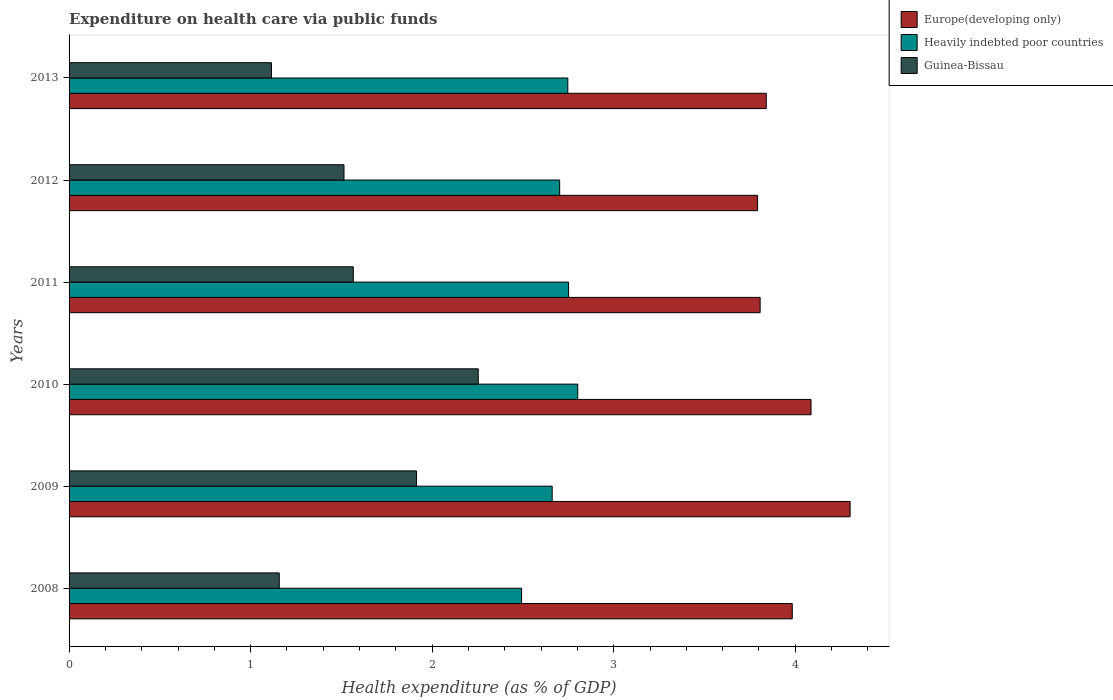How many different coloured bars are there?
Your answer should be compact. 3. How many groups of bars are there?
Make the answer very short. 6. Are the number of bars on each tick of the Y-axis equal?
Provide a short and direct response. Yes. How many bars are there on the 5th tick from the bottom?
Keep it short and to the point. 3. What is the label of the 4th group of bars from the top?
Provide a succinct answer. 2010. In how many cases, is the number of bars for a given year not equal to the number of legend labels?
Your response must be concise. 0. What is the expenditure made on health care in Guinea-Bissau in 2008?
Your answer should be compact. 1.16. Across all years, what is the maximum expenditure made on health care in Heavily indebted poor countries?
Provide a succinct answer. 2.8. Across all years, what is the minimum expenditure made on health care in Europe(developing only)?
Ensure brevity in your answer.  3.79. In which year was the expenditure made on health care in Europe(developing only) maximum?
Keep it short and to the point. 2009. In which year was the expenditure made on health care in Europe(developing only) minimum?
Your answer should be very brief. 2012. What is the total expenditure made on health care in Guinea-Bissau in the graph?
Give a very brief answer. 9.52. What is the difference between the expenditure made on health care in Guinea-Bissau in 2010 and that in 2011?
Offer a terse response. 0.69. What is the difference between the expenditure made on health care in Guinea-Bissau in 2010 and the expenditure made on health care in Europe(developing only) in 2008?
Give a very brief answer. -1.73. What is the average expenditure made on health care in Europe(developing only) per year?
Offer a very short reply. 3.97. In the year 2011, what is the difference between the expenditure made on health care in Europe(developing only) and expenditure made on health care in Guinea-Bissau?
Your response must be concise. 2.24. In how many years, is the expenditure made on health care in Europe(developing only) greater than 2.8 %?
Offer a terse response. 6. What is the ratio of the expenditure made on health care in Guinea-Bissau in 2010 to that in 2011?
Your answer should be very brief. 1.44. Is the difference between the expenditure made on health care in Europe(developing only) in 2010 and 2012 greater than the difference between the expenditure made on health care in Guinea-Bissau in 2010 and 2012?
Your response must be concise. No. What is the difference between the highest and the second highest expenditure made on health care in Guinea-Bissau?
Your response must be concise. 0.34. What is the difference between the highest and the lowest expenditure made on health care in Europe(developing only)?
Provide a succinct answer. 0.51. In how many years, is the expenditure made on health care in Heavily indebted poor countries greater than the average expenditure made on health care in Heavily indebted poor countries taken over all years?
Your answer should be compact. 4. What does the 1st bar from the top in 2010 represents?
Your response must be concise. Guinea-Bissau. What does the 2nd bar from the bottom in 2013 represents?
Offer a very short reply. Heavily indebted poor countries. Is it the case that in every year, the sum of the expenditure made on health care in Guinea-Bissau and expenditure made on health care in Heavily indebted poor countries is greater than the expenditure made on health care in Europe(developing only)?
Ensure brevity in your answer.  No. How many bars are there?
Provide a short and direct response. 18. What is the difference between two consecutive major ticks on the X-axis?
Offer a very short reply. 1. Are the values on the major ticks of X-axis written in scientific E-notation?
Keep it short and to the point. No. Where does the legend appear in the graph?
Keep it short and to the point. Top right. How many legend labels are there?
Provide a short and direct response. 3. How are the legend labels stacked?
Provide a succinct answer. Vertical. What is the title of the graph?
Keep it short and to the point. Expenditure on health care via public funds. Does "Sint Maarten (Dutch part)" appear as one of the legend labels in the graph?
Give a very brief answer. No. What is the label or title of the X-axis?
Offer a very short reply. Health expenditure (as % of GDP). What is the Health expenditure (as % of GDP) of Europe(developing only) in 2008?
Provide a succinct answer. 3.98. What is the Health expenditure (as % of GDP) in Heavily indebted poor countries in 2008?
Provide a succinct answer. 2.49. What is the Health expenditure (as % of GDP) in Guinea-Bissau in 2008?
Your response must be concise. 1.16. What is the Health expenditure (as % of GDP) of Europe(developing only) in 2009?
Provide a short and direct response. 4.3. What is the Health expenditure (as % of GDP) in Heavily indebted poor countries in 2009?
Offer a very short reply. 2.66. What is the Health expenditure (as % of GDP) of Guinea-Bissau in 2009?
Your answer should be compact. 1.91. What is the Health expenditure (as % of GDP) of Europe(developing only) in 2010?
Make the answer very short. 4.09. What is the Health expenditure (as % of GDP) in Heavily indebted poor countries in 2010?
Your answer should be compact. 2.8. What is the Health expenditure (as % of GDP) in Guinea-Bissau in 2010?
Give a very brief answer. 2.25. What is the Health expenditure (as % of GDP) of Europe(developing only) in 2011?
Provide a succinct answer. 3.81. What is the Health expenditure (as % of GDP) in Heavily indebted poor countries in 2011?
Make the answer very short. 2.75. What is the Health expenditure (as % of GDP) of Guinea-Bissau in 2011?
Provide a short and direct response. 1.57. What is the Health expenditure (as % of GDP) of Europe(developing only) in 2012?
Provide a short and direct response. 3.79. What is the Health expenditure (as % of GDP) in Heavily indebted poor countries in 2012?
Offer a very short reply. 2.7. What is the Health expenditure (as % of GDP) in Guinea-Bissau in 2012?
Offer a terse response. 1.51. What is the Health expenditure (as % of GDP) in Europe(developing only) in 2013?
Offer a terse response. 3.84. What is the Health expenditure (as % of GDP) of Heavily indebted poor countries in 2013?
Your answer should be very brief. 2.75. What is the Health expenditure (as % of GDP) in Guinea-Bissau in 2013?
Keep it short and to the point. 1.11. Across all years, what is the maximum Health expenditure (as % of GDP) in Europe(developing only)?
Your answer should be very brief. 4.3. Across all years, what is the maximum Health expenditure (as % of GDP) in Heavily indebted poor countries?
Your answer should be compact. 2.8. Across all years, what is the maximum Health expenditure (as % of GDP) of Guinea-Bissau?
Offer a very short reply. 2.25. Across all years, what is the minimum Health expenditure (as % of GDP) in Europe(developing only)?
Your response must be concise. 3.79. Across all years, what is the minimum Health expenditure (as % of GDP) in Heavily indebted poor countries?
Give a very brief answer. 2.49. Across all years, what is the minimum Health expenditure (as % of GDP) of Guinea-Bissau?
Your answer should be compact. 1.11. What is the total Health expenditure (as % of GDP) in Europe(developing only) in the graph?
Offer a terse response. 23.81. What is the total Health expenditure (as % of GDP) in Heavily indebted poor countries in the graph?
Your response must be concise. 16.16. What is the total Health expenditure (as % of GDP) in Guinea-Bissau in the graph?
Provide a succinct answer. 9.52. What is the difference between the Health expenditure (as % of GDP) of Europe(developing only) in 2008 and that in 2009?
Offer a terse response. -0.32. What is the difference between the Health expenditure (as % of GDP) in Heavily indebted poor countries in 2008 and that in 2009?
Your answer should be compact. -0.17. What is the difference between the Health expenditure (as % of GDP) in Guinea-Bissau in 2008 and that in 2009?
Ensure brevity in your answer.  -0.76. What is the difference between the Health expenditure (as % of GDP) of Europe(developing only) in 2008 and that in 2010?
Your answer should be very brief. -0.1. What is the difference between the Health expenditure (as % of GDP) of Heavily indebted poor countries in 2008 and that in 2010?
Provide a succinct answer. -0.31. What is the difference between the Health expenditure (as % of GDP) of Guinea-Bissau in 2008 and that in 2010?
Make the answer very short. -1.1. What is the difference between the Health expenditure (as % of GDP) in Europe(developing only) in 2008 and that in 2011?
Make the answer very short. 0.18. What is the difference between the Health expenditure (as % of GDP) in Heavily indebted poor countries in 2008 and that in 2011?
Your answer should be compact. -0.26. What is the difference between the Health expenditure (as % of GDP) of Guinea-Bissau in 2008 and that in 2011?
Provide a short and direct response. -0.41. What is the difference between the Health expenditure (as % of GDP) of Europe(developing only) in 2008 and that in 2012?
Your answer should be compact. 0.19. What is the difference between the Health expenditure (as % of GDP) of Heavily indebted poor countries in 2008 and that in 2012?
Ensure brevity in your answer.  -0.21. What is the difference between the Health expenditure (as % of GDP) in Guinea-Bissau in 2008 and that in 2012?
Your answer should be compact. -0.36. What is the difference between the Health expenditure (as % of GDP) in Europe(developing only) in 2008 and that in 2013?
Provide a short and direct response. 0.14. What is the difference between the Health expenditure (as % of GDP) of Heavily indebted poor countries in 2008 and that in 2013?
Offer a very short reply. -0.25. What is the difference between the Health expenditure (as % of GDP) in Guinea-Bissau in 2008 and that in 2013?
Offer a terse response. 0.04. What is the difference between the Health expenditure (as % of GDP) in Europe(developing only) in 2009 and that in 2010?
Your answer should be compact. 0.22. What is the difference between the Health expenditure (as % of GDP) in Heavily indebted poor countries in 2009 and that in 2010?
Offer a very short reply. -0.14. What is the difference between the Health expenditure (as % of GDP) in Guinea-Bissau in 2009 and that in 2010?
Provide a short and direct response. -0.34. What is the difference between the Health expenditure (as % of GDP) of Europe(developing only) in 2009 and that in 2011?
Your answer should be very brief. 0.5. What is the difference between the Health expenditure (as % of GDP) in Heavily indebted poor countries in 2009 and that in 2011?
Ensure brevity in your answer.  -0.09. What is the difference between the Health expenditure (as % of GDP) in Guinea-Bissau in 2009 and that in 2011?
Offer a terse response. 0.35. What is the difference between the Health expenditure (as % of GDP) of Europe(developing only) in 2009 and that in 2012?
Give a very brief answer. 0.51. What is the difference between the Health expenditure (as % of GDP) of Heavily indebted poor countries in 2009 and that in 2012?
Your answer should be very brief. -0.04. What is the difference between the Health expenditure (as % of GDP) of Guinea-Bissau in 2009 and that in 2012?
Keep it short and to the point. 0.4. What is the difference between the Health expenditure (as % of GDP) in Europe(developing only) in 2009 and that in 2013?
Provide a succinct answer. 0.46. What is the difference between the Health expenditure (as % of GDP) of Heavily indebted poor countries in 2009 and that in 2013?
Your answer should be compact. -0.09. What is the difference between the Health expenditure (as % of GDP) of Guinea-Bissau in 2009 and that in 2013?
Your answer should be very brief. 0.8. What is the difference between the Health expenditure (as % of GDP) in Europe(developing only) in 2010 and that in 2011?
Your answer should be very brief. 0.28. What is the difference between the Health expenditure (as % of GDP) in Heavily indebted poor countries in 2010 and that in 2011?
Offer a terse response. 0.05. What is the difference between the Health expenditure (as % of GDP) in Guinea-Bissau in 2010 and that in 2011?
Your answer should be compact. 0.69. What is the difference between the Health expenditure (as % of GDP) of Europe(developing only) in 2010 and that in 2012?
Ensure brevity in your answer.  0.29. What is the difference between the Health expenditure (as % of GDP) of Heavily indebted poor countries in 2010 and that in 2012?
Provide a succinct answer. 0.1. What is the difference between the Health expenditure (as % of GDP) of Guinea-Bissau in 2010 and that in 2012?
Your answer should be very brief. 0.74. What is the difference between the Health expenditure (as % of GDP) of Europe(developing only) in 2010 and that in 2013?
Offer a very short reply. 0.25. What is the difference between the Health expenditure (as % of GDP) in Heavily indebted poor countries in 2010 and that in 2013?
Make the answer very short. 0.05. What is the difference between the Health expenditure (as % of GDP) in Guinea-Bissau in 2010 and that in 2013?
Provide a succinct answer. 1.14. What is the difference between the Health expenditure (as % of GDP) of Europe(developing only) in 2011 and that in 2012?
Offer a very short reply. 0.01. What is the difference between the Health expenditure (as % of GDP) in Heavily indebted poor countries in 2011 and that in 2012?
Your answer should be very brief. 0.05. What is the difference between the Health expenditure (as % of GDP) in Guinea-Bissau in 2011 and that in 2012?
Offer a terse response. 0.05. What is the difference between the Health expenditure (as % of GDP) of Europe(developing only) in 2011 and that in 2013?
Ensure brevity in your answer.  -0.03. What is the difference between the Health expenditure (as % of GDP) of Heavily indebted poor countries in 2011 and that in 2013?
Your answer should be compact. 0. What is the difference between the Health expenditure (as % of GDP) of Guinea-Bissau in 2011 and that in 2013?
Make the answer very short. 0.45. What is the difference between the Health expenditure (as % of GDP) in Europe(developing only) in 2012 and that in 2013?
Offer a terse response. -0.05. What is the difference between the Health expenditure (as % of GDP) in Heavily indebted poor countries in 2012 and that in 2013?
Ensure brevity in your answer.  -0.04. What is the difference between the Health expenditure (as % of GDP) of Guinea-Bissau in 2012 and that in 2013?
Offer a terse response. 0.4. What is the difference between the Health expenditure (as % of GDP) in Europe(developing only) in 2008 and the Health expenditure (as % of GDP) in Heavily indebted poor countries in 2009?
Your answer should be compact. 1.32. What is the difference between the Health expenditure (as % of GDP) of Europe(developing only) in 2008 and the Health expenditure (as % of GDP) of Guinea-Bissau in 2009?
Ensure brevity in your answer.  2.07. What is the difference between the Health expenditure (as % of GDP) in Heavily indebted poor countries in 2008 and the Health expenditure (as % of GDP) in Guinea-Bissau in 2009?
Your answer should be compact. 0.58. What is the difference between the Health expenditure (as % of GDP) of Europe(developing only) in 2008 and the Health expenditure (as % of GDP) of Heavily indebted poor countries in 2010?
Offer a terse response. 1.18. What is the difference between the Health expenditure (as % of GDP) in Europe(developing only) in 2008 and the Health expenditure (as % of GDP) in Guinea-Bissau in 2010?
Provide a short and direct response. 1.73. What is the difference between the Health expenditure (as % of GDP) in Heavily indebted poor countries in 2008 and the Health expenditure (as % of GDP) in Guinea-Bissau in 2010?
Your response must be concise. 0.24. What is the difference between the Health expenditure (as % of GDP) in Europe(developing only) in 2008 and the Health expenditure (as % of GDP) in Heavily indebted poor countries in 2011?
Provide a short and direct response. 1.23. What is the difference between the Health expenditure (as % of GDP) in Europe(developing only) in 2008 and the Health expenditure (as % of GDP) in Guinea-Bissau in 2011?
Give a very brief answer. 2.42. What is the difference between the Health expenditure (as % of GDP) in Heavily indebted poor countries in 2008 and the Health expenditure (as % of GDP) in Guinea-Bissau in 2011?
Ensure brevity in your answer.  0.93. What is the difference between the Health expenditure (as % of GDP) in Europe(developing only) in 2008 and the Health expenditure (as % of GDP) in Heavily indebted poor countries in 2012?
Ensure brevity in your answer.  1.28. What is the difference between the Health expenditure (as % of GDP) of Europe(developing only) in 2008 and the Health expenditure (as % of GDP) of Guinea-Bissau in 2012?
Offer a very short reply. 2.47. What is the difference between the Health expenditure (as % of GDP) of Heavily indebted poor countries in 2008 and the Health expenditure (as % of GDP) of Guinea-Bissau in 2012?
Ensure brevity in your answer.  0.98. What is the difference between the Health expenditure (as % of GDP) in Europe(developing only) in 2008 and the Health expenditure (as % of GDP) in Heavily indebted poor countries in 2013?
Give a very brief answer. 1.24. What is the difference between the Health expenditure (as % of GDP) in Europe(developing only) in 2008 and the Health expenditure (as % of GDP) in Guinea-Bissau in 2013?
Provide a short and direct response. 2.87. What is the difference between the Health expenditure (as % of GDP) of Heavily indebted poor countries in 2008 and the Health expenditure (as % of GDP) of Guinea-Bissau in 2013?
Provide a short and direct response. 1.38. What is the difference between the Health expenditure (as % of GDP) in Europe(developing only) in 2009 and the Health expenditure (as % of GDP) in Heavily indebted poor countries in 2010?
Give a very brief answer. 1.5. What is the difference between the Health expenditure (as % of GDP) in Europe(developing only) in 2009 and the Health expenditure (as % of GDP) in Guinea-Bissau in 2010?
Keep it short and to the point. 2.05. What is the difference between the Health expenditure (as % of GDP) of Heavily indebted poor countries in 2009 and the Health expenditure (as % of GDP) of Guinea-Bissau in 2010?
Keep it short and to the point. 0.41. What is the difference between the Health expenditure (as % of GDP) in Europe(developing only) in 2009 and the Health expenditure (as % of GDP) in Heavily indebted poor countries in 2011?
Make the answer very short. 1.55. What is the difference between the Health expenditure (as % of GDP) of Europe(developing only) in 2009 and the Health expenditure (as % of GDP) of Guinea-Bissau in 2011?
Make the answer very short. 2.74. What is the difference between the Health expenditure (as % of GDP) of Heavily indebted poor countries in 2009 and the Health expenditure (as % of GDP) of Guinea-Bissau in 2011?
Keep it short and to the point. 1.1. What is the difference between the Health expenditure (as % of GDP) in Europe(developing only) in 2009 and the Health expenditure (as % of GDP) in Heavily indebted poor countries in 2012?
Give a very brief answer. 1.6. What is the difference between the Health expenditure (as % of GDP) of Europe(developing only) in 2009 and the Health expenditure (as % of GDP) of Guinea-Bissau in 2012?
Give a very brief answer. 2.79. What is the difference between the Health expenditure (as % of GDP) of Heavily indebted poor countries in 2009 and the Health expenditure (as % of GDP) of Guinea-Bissau in 2012?
Provide a short and direct response. 1.15. What is the difference between the Health expenditure (as % of GDP) of Europe(developing only) in 2009 and the Health expenditure (as % of GDP) of Heavily indebted poor countries in 2013?
Make the answer very short. 1.55. What is the difference between the Health expenditure (as % of GDP) of Europe(developing only) in 2009 and the Health expenditure (as % of GDP) of Guinea-Bissau in 2013?
Ensure brevity in your answer.  3.19. What is the difference between the Health expenditure (as % of GDP) in Heavily indebted poor countries in 2009 and the Health expenditure (as % of GDP) in Guinea-Bissau in 2013?
Keep it short and to the point. 1.55. What is the difference between the Health expenditure (as % of GDP) in Europe(developing only) in 2010 and the Health expenditure (as % of GDP) in Heavily indebted poor countries in 2011?
Make the answer very short. 1.34. What is the difference between the Health expenditure (as % of GDP) in Europe(developing only) in 2010 and the Health expenditure (as % of GDP) in Guinea-Bissau in 2011?
Provide a short and direct response. 2.52. What is the difference between the Health expenditure (as % of GDP) of Heavily indebted poor countries in 2010 and the Health expenditure (as % of GDP) of Guinea-Bissau in 2011?
Give a very brief answer. 1.24. What is the difference between the Health expenditure (as % of GDP) in Europe(developing only) in 2010 and the Health expenditure (as % of GDP) in Heavily indebted poor countries in 2012?
Your answer should be compact. 1.38. What is the difference between the Health expenditure (as % of GDP) of Europe(developing only) in 2010 and the Health expenditure (as % of GDP) of Guinea-Bissau in 2012?
Keep it short and to the point. 2.57. What is the difference between the Health expenditure (as % of GDP) in Heavily indebted poor countries in 2010 and the Health expenditure (as % of GDP) in Guinea-Bissau in 2012?
Give a very brief answer. 1.29. What is the difference between the Health expenditure (as % of GDP) of Europe(developing only) in 2010 and the Health expenditure (as % of GDP) of Heavily indebted poor countries in 2013?
Provide a succinct answer. 1.34. What is the difference between the Health expenditure (as % of GDP) of Europe(developing only) in 2010 and the Health expenditure (as % of GDP) of Guinea-Bissau in 2013?
Offer a very short reply. 2.97. What is the difference between the Health expenditure (as % of GDP) of Heavily indebted poor countries in 2010 and the Health expenditure (as % of GDP) of Guinea-Bissau in 2013?
Make the answer very short. 1.69. What is the difference between the Health expenditure (as % of GDP) of Europe(developing only) in 2011 and the Health expenditure (as % of GDP) of Heavily indebted poor countries in 2012?
Give a very brief answer. 1.1. What is the difference between the Health expenditure (as % of GDP) of Europe(developing only) in 2011 and the Health expenditure (as % of GDP) of Guinea-Bissau in 2012?
Ensure brevity in your answer.  2.29. What is the difference between the Health expenditure (as % of GDP) of Heavily indebted poor countries in 2011 and the Health expenditure (as % of GDP) of Guinea-Bissau in 2012?
Your response must be concise. 1.24. What is the difference between the Health expenditure (as % of GDP) of Europe(developing only) in 2011 and the Health expenditure (as % of GDP) of Heavily indebted poor countries in 2013?
Make the answer very short. 1.06. What is the difference between the Health expenditure (as % of GDP) in Europe(developing only) in 2011 and the Health expenditure (as % of GDP) in Guinea-Bissau in 2013?
Ensure brevity in your answer.  2.69. What is the difference between the Health expenditure (as % of GDP) of Heavily indebted poor countries in 2011 and the Health expenditure (as % of GDP) of Guinea-Bissau in 2013?
Offer a terse response. 1.64. What is the difference between the Health expenditure (as % of GDP) of Europe(developing only) in 2012 and the Health expenditure (as % of GDP) of Heavily indebted poor countries in 2013?
Provide a short and direct response. 1.05. What is the difference between the Health expenditure (as % of GDP) in Europe(developing only) in 2012 and the Health expenditure (as % of GDP) in Guinea-Bissau in 2013?
Ensure brevity in your answer.  2.68. What is the difference between the Health expenditure (as % of GDP) in Heavily indebted poor countries in 2012 and the Health expenditure (as % of GDP) in Guinea-Bissau in 2013?
Your answer should be very brief. 1.59. What is the average Health expenditure (as % of GDP) of Europe(developing only) per year?
Provide a succinct answer. 3.97. What is the average Health expenditure (as % of GDP) in Heavily indebted poor countries per year?
Your answer should be very brief. 2.69. What is the average Health expenditure (as % of GDP) of Guinea-Bissau per year?
Provide a short and direct response. 1.59. In the year 2008, what is the difference between the Health expenditure (as % of GDP) in Europe(developing only) and Health expenditure (as % of GDP) in Heavily indebted poor countries?
Your answer should be compact. 1.49. In the year 2008, what is the difference between the Health expenditure (as % of GDP) of Europe(developing only) and Health expenditure (as % of GDP) of Guinea-Bissau?
Your response must be concise. 2.83. In the year 2008, what is the difference between the Health expenditure (as % of GDP) of Heavily indebted poor countries and Health expenditure (as % of GDP) of Guinea-Bissau?
Make the answer very short. 1.33. In the year 2009, what is the difference between the Health expenditure (as % of GDP) in Europe(developing only) and Health expenditure (as % of GDP) in Heavily indebted poor countries?
Your answer should be very brief. 1.64. In the year 2009, what is the difference between the Health expenditure (as % of GDP) in Europe(developing only) and Health expenditure (as % of GDP) in Guinea-Bissau?
Your answer should be very brief. 2.39. In the year 2009, what is the difference between the Health expenditure (as % of GDP) of Heavily indebted poor countries and Health expenditure (as % of GDP) of Guinea-Bissau?
Offer a terse response. 0.75. In the year 2010, what is the difference between the Health expenditure (as % of GDP) in Europe(developing only) and Health expenditure (as % of GDP) in Heavily indebted poor countries?
Offer a terse response. 1.28. In the year 2010, what is the difference between the Health expenditure (as % of GDP) in Europe(developing only) and Health expenditure (as % of GDP) in Guinea-Bissau?
Your answer should be compact. 1.83. In the year 2010, what is the difference between the Health expenditure (as % of GDP) of Heavily indebted poor countries and Health expenditure (as % of GDP) of Guinea-Bissau?
Provide a short and direct response. 0.55. In the year 2011, what is the difference between the Health expenditure (as % of GDP) in Europe(developing only) and Health expenditure (as % of GDP) in Heavily indebted poor countries?
Give a very brief answer. 1.06. In the year 2011, what is the difference between the Health expenditure (as % of GDP) of Europe(developing only) and Health expenditure (as % of GDP) of Guinea-Bissau?
Your answer should be compact. 2.24. In the year 2011, what is the difference between the Health expenditure (as % of GDP) in Heavily indebted poor countries and Health expenditure (as % of GDP) in Guinea-Bissau?
Offer a very short reply. 1.19. In the year 2012, what is the difference between the Health expenditure (as % of GDP) of Europe(developing only) and Health expenditure (as % of GDP) of Heavily indebted poor countries?
Provide a succinct answer. 1.09. In the year 2012, what is the difference between the Health expenditure (as % of GDP) of Europe(developing only) and Health expenditure (as % of GDP) of Guinea-Bissau?
Your answer should be compact. 2.28. In the year 2012, what is the difference between the Health expenditure (as % of GDP) of Heavily indebted poor countries and Health expenditure (as % of GDP) of Guinea-Bissau?
Ensure brevity in your answer.  1.19. In the year 2013, what is the difference between the Health expenditure (as % of GDP) in Europe(developing only) and Health expenditure (as % of GDP) in Heavily indebted poor countries?
Ensure brevity in your answer.  1.09. In the year 2013, what is the difference between the Health expenditure (as % of GDP) of Europe(developing only) and Health expenditure (as % of GDP) of Guinea-Bissau?
Your answer should be compact. 2.73. In the year 2013, what is the difference between the Health expenditure (as % of GDP) in Heavily indebted poor countries and Health expenditure (as % of GDP) in Guinea-Bissau?
Offer a terse response. 1.63. What is the ratio of the Health expenditure (as % of GDP) of Europe(developing only) in 2008 to that in 2009?
Provide a succinct answer. 0.93. What is the ratio of the Health expenditure (as % of GDP) in Heavily indebted poor countries in 2008 to that in 2009?
Your answer should be very brief. 0.94. What is the ratio of the Health expenditure (as % of GDP) in Guinea-Bissau in 2008 to that in 2009?
Ensure brevity in your answer.  0.6. What is the ratio of the Health expenditure (as % of GDP) in Europe(developing only) in 2008 to that in 2010?
Ensure brevity in your answer.  0.97. What is the ratio of the Health expenditure (as % of GDP) in Heavily indebted poor countries in 2008 to that in 2010?
Ensure brevity in your answer.  0.89. What is the ratio of the Health expenditure (as % of GDP) of Guinea-Bissau in 2008 to that in 2010?
Give a very brief answer. 0.51. What is the ratio of the Health expenditure (as % of GDP) in Europe(developing only) in 2008 to that in 2011?
Your answer should be compact. 1.05. What is the ratio of the Health expenditure (as % of GDP) in Heavily indebted poor countries in 2008 to that in 2011?
Keep it short and to the point. 0.91. What is the ratio of the Health expenditure (as % of GDP) of Guinea-Bissau in 2008 to that in 2011?
Offer a terse response. 0.74. What is the ratio of the Health expenditure (as % of GDP) in Europe(developing only) in 2008 to that in 2012?
Your answer should be compact. 1.05. What is the ratio of the Health expenditure (as % of GDP) in Heavily indebted poor countries in 2008 to that in 2012?
Keep it short and to the point. 0.92. What is the ratio of the Health expenditure (as % of GDP) in Guinea-Bissau in 2008 to that in 2012?
Offer a terse response. 0.76. What is the ratio of the Health expenditure (as % of GDP) in Europe(developing only) in 2008 to that in 2013?
Give a very brief answer. 1.04. What is the ratio of the Health expenditure (as % of GDP) in Heavily indebted poor countries in 2008 to that in 2013?
Keep it short and to the point. 0.91. What is the ratio of the Health expenditure (as % of GDP) of Guinea-Bissau in 2008 to that in 2013?
Offer a terse response. 1.04. What is the ratio of the Health expenditure (as % of GDP) of Europe(developing only) in 2009 to that in 2010?
Your response must be concise. 1.05. What is the ratio of the Health expenditure (as % of GDP) in Heavily indebted poor countries in 2009 to that in 2010?
Ensure brevity in your answer.  0.95. What is the ratio of the Health expenditure (as % of GDP) in Guinea-Bissau in 2009 to that in 2010?
Offer a very short reply. 0.85. What is the ratio of the Health expenditure (as % of GDP) in Europe(developing only) in 2009 to that in 2011?
Ensure brevity in your answer.  1.13. What is the ratio of the Health expenditure (as % of GDP) of Heavily indebted poor countries in 2009 to that in 2011?
Your answer should be compact. 0.97. What is the ratio of the Health expenditure (as % of GDP) of Guinea-Bissau in 2009 to that in 2011?
Provide a succinct answer. 1.22. What is the ratio of the Health expenditure (as % of GDP) in Europe(developing only) in 2009 to that in 2012?
Your response must be concise. 1.13. What is the ratio of the Health expenditure (as % of GDP) of Heavily indebted poor countries in 2009 to that in 2012?
Your response must be concise. 0.98. What is the ratio of the Health expenditure (as % of GDP) of Guinea-Bissau in 2009 to that in 2012?
Give a very brief answer. 1.26. What is the ratio of the Health expenditure (as % of GDP) of Europe(developing only) in 2009 to that in 2013?
Your answer should be very brief. 1.12. What is the ratio of the Health expenditure (as % of GDP) in Heavily indebted poor countries in 2009 to that in 2013?
Provide a short and direct response. 0.97. What is the ratio of the Health expenditure (as % of GDP) in Guinea-Bissau in 2009 to that in 2013?
Give a very brief answer. 1.72. What is the ratio of the Health expenditure (as % of GDP) in Europe(developing only) in 2010 to that in 2011?
Offer a terse response. 1.07. What is the ratio of the Health expenditure (as % of GDP) of Heavily indebted poor countries in 2010 to that in 2011?
Provide a short and direct response. 1.02. What is the ratio of the Health expenditure (as % of GDP) of Guinea-Bissau in 2010 to that in 2011?
Offer a very short reply. 1.44. What is the ratio of the Health expenditure (as % of GDP) in Europe(developing only) in 2010 to that in 2012?
Your answer should be very brief. 1.08. What is the ratio of the Health expenditure (as % of GDP) of Heavily indebted poor countries in 2010 to that in 2012?
Your answer should be very brief. 1.04. What is the ratio of the Health expenditure (as % of GDP) of Guinea-Bissau in 2010 to that in 2012?
Provide a short and direct response. 1.49. What is the ratio of the Health expenditure (as % of GDP) of Europe(developing only) in 2010 to that in 2013?
Your response must be concise. 1.06. What is the ratio of the Health expenditure (as % of GDP) in Heavily indebted poor countries in 2010 to that in 2013?
Offer a terse response. 1.02. What is the ratio of the Health expenditure (as % of GDP) in Guinea-Bissau in 2010 to that in 2013?
Give a very brief answer. 2.02. What is the ratio of the Health expenditure (as % of GDP) of Heavily indebted poor countries in 2011 to that in 2012?
Your answer should be very brief. 1.02. What is the ratio of the Health expenditure (as % of GDP) of Guinea-Bissau in 2011 to that in 2012?
Your response must be concise. 1.03. What is the ratio of the Health expenditure (as % of GDP) of Europe(developing only) in 2011 to that in 2013?
Make the answer very short. 0.99. What is the ratio of the Health expenditure (as % of GDP) in Heavily indebted poor countries in 2011 to that in 2013?
Your answer should be compact. 1. What is the ratio of the Health expenditure (as % of GDP) in Guinea-Bissau in 2011 to that in 2013?
Offer a terse response. 1.4. What is the ratio of the Health expenditure (as % of GDP) in Europe(developing only) in 2012 to that in 2013?
Provide a succinct answer. 0.99. What is the ratio of the Health expenditure (as % of GDP) in Heavily indebted poor countries in 2012 to that in 2013?
Offer a terse response. 0.98. What is the ratio of the Health expenditure (as % of GDP) in Guinea-Bissau in 2012 to that in 2013?
Ensure brevity in your answer.  1.36. What is the difference between the highest and the second highest Health expenditure (as % of GDP) in Europe(developing only)?
Your answer should be compact. 0.22. What is the difference between the highest and the second highest Health expenditure (as % of GDP) of Heavily indebted poor countries?
Give a very brief answer. 0.05. What is the difference between the highest and the second highest Health expenditure (as % of GDP) of Guinea-Bissau?
Offer a very short reply. 0.34. What is the difference between the highest and the lowest Health expenditure (as % of GDP) of Europe(developing only)?
Keep it short and to the point. 0.51. What is the difference between the highest and the lowest Health expenditure (as % of GDP) in Heavily indebted poor countries?
Provide a short and direct response. 0.31. What is the difference between the highest and the lowest Health expenditure (as % of GDP) of Guinea-Bissau?
Offer a terse response. 1.14. 